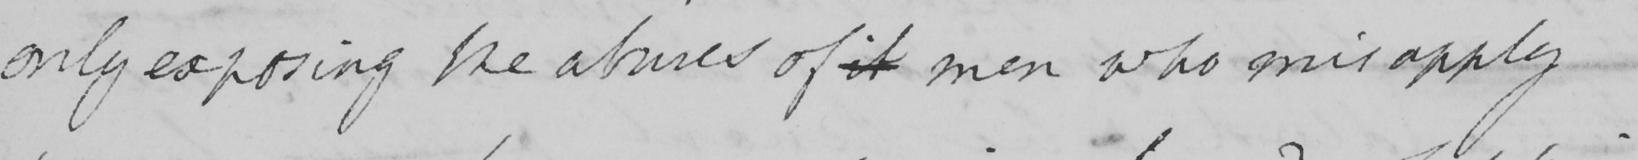What is written in this line of handwriting? only exposing the abuses of it men who misapply 